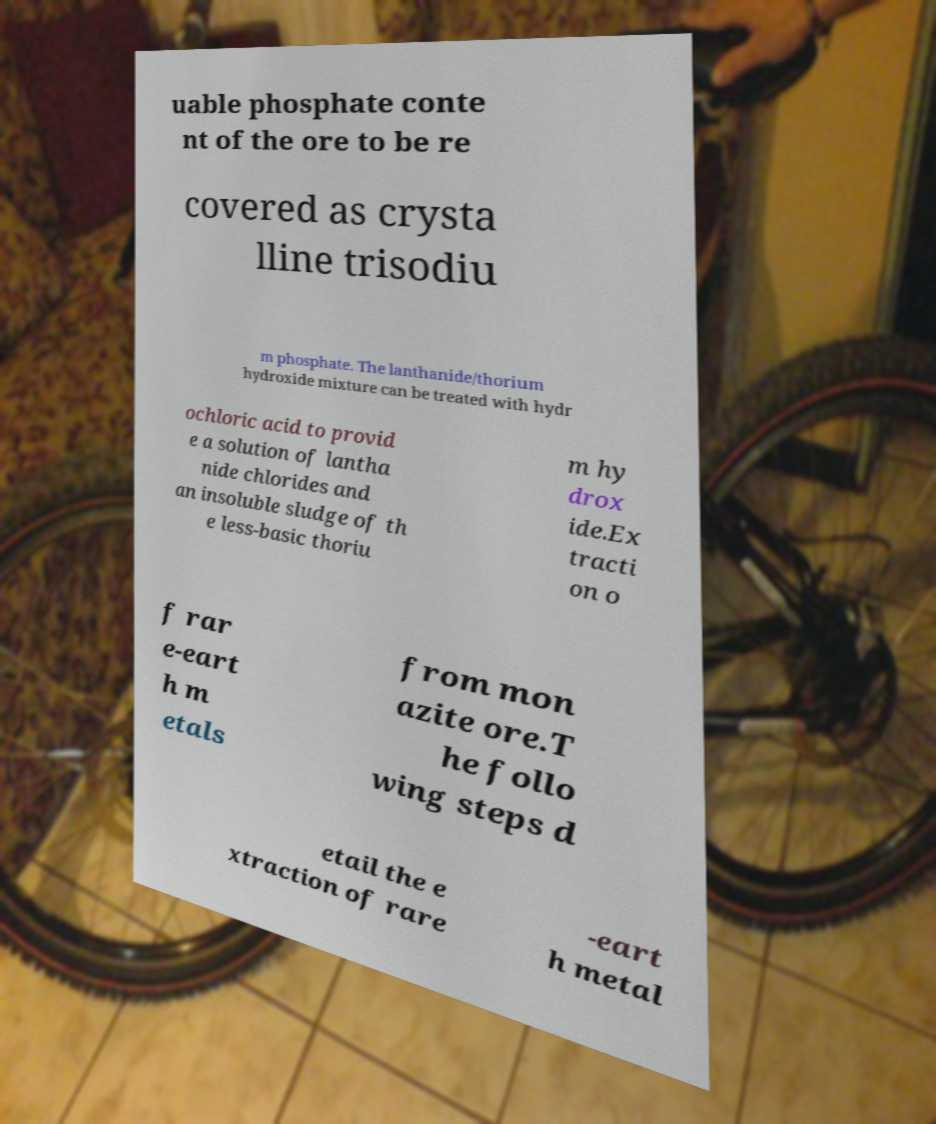I need the written content from this picture converted into text. Can you do that? uable phosphate conte nt of the ore to be re covered as crysta lline trisodiu m phosphate. The lanthanide/thorium hydroxide mixture can be treated with hydr ochloric acid to provid e a solution of lantha nide chlorides and an insoluble sludge of th e less-basic thoriu m hy drox ide.Ex tracti on o f rar e-eart h m etals from mon azite ore.T he follo wing steps d etail the e xtraction of rare -eart h metal 